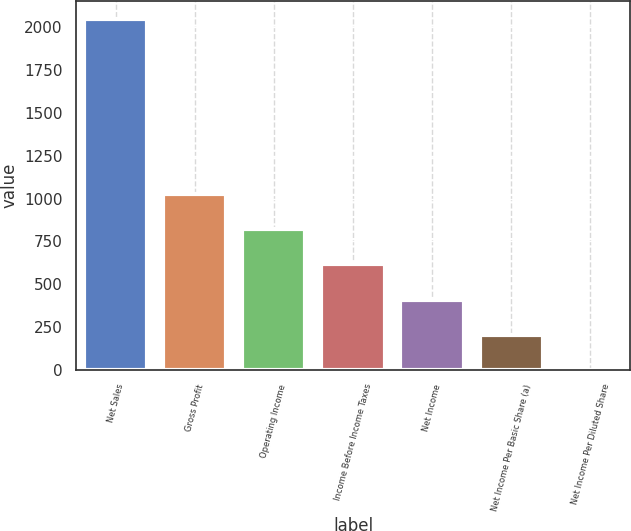<chart> <loc_0><loc_0><loc_500><loc_500><bar_chart><fcel>Net Sales<fcel>Gross Profit<fcel>Operating Income<fcel>Income Before Income Taxes<fcel>Net Income<fcel>Net Income Per Basic Share (a)<fcel>Net Income Per Diluted Share<nl><fcel>2050<fcel>1025.12<fcel>820.15<fcel>615.18<fcel>410.21<fcel>205.23<fcel>0.25<nl></chart> 